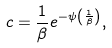<formula> <loc_0><loc_0><loc_500><loc_500>c = \frac { 1 } { \beta } e ^ { - \psi \left ( \frac { 1 } { \beta } \right ) } ,</formula> 